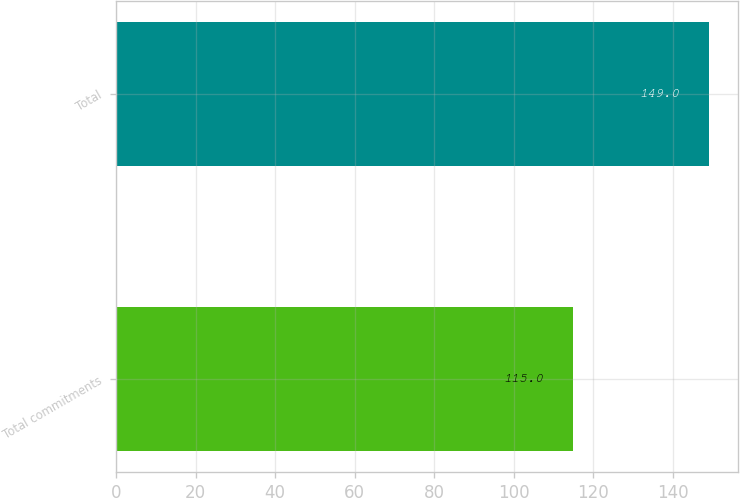Convert chart to OTSL. <chart><loc_0><loc_0><loc_500><loc_500><bar_chart><fcel>Total commitments<fcel>Total<nl><fcel>115<fcel>149<nl></chart> 